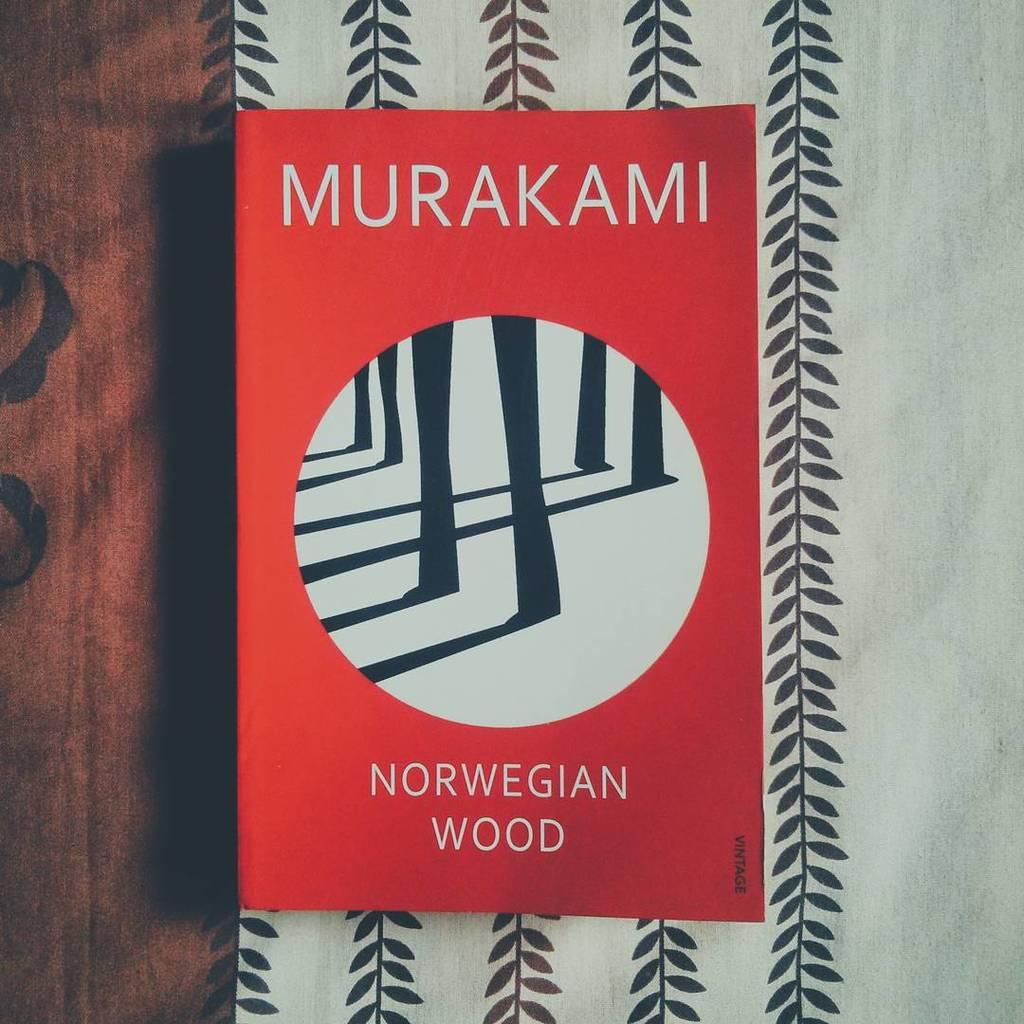<image>
Relay a brief, clear account of the picture shown. A book titled Norwegian Wood features a red cover with black lines in a white circle. 